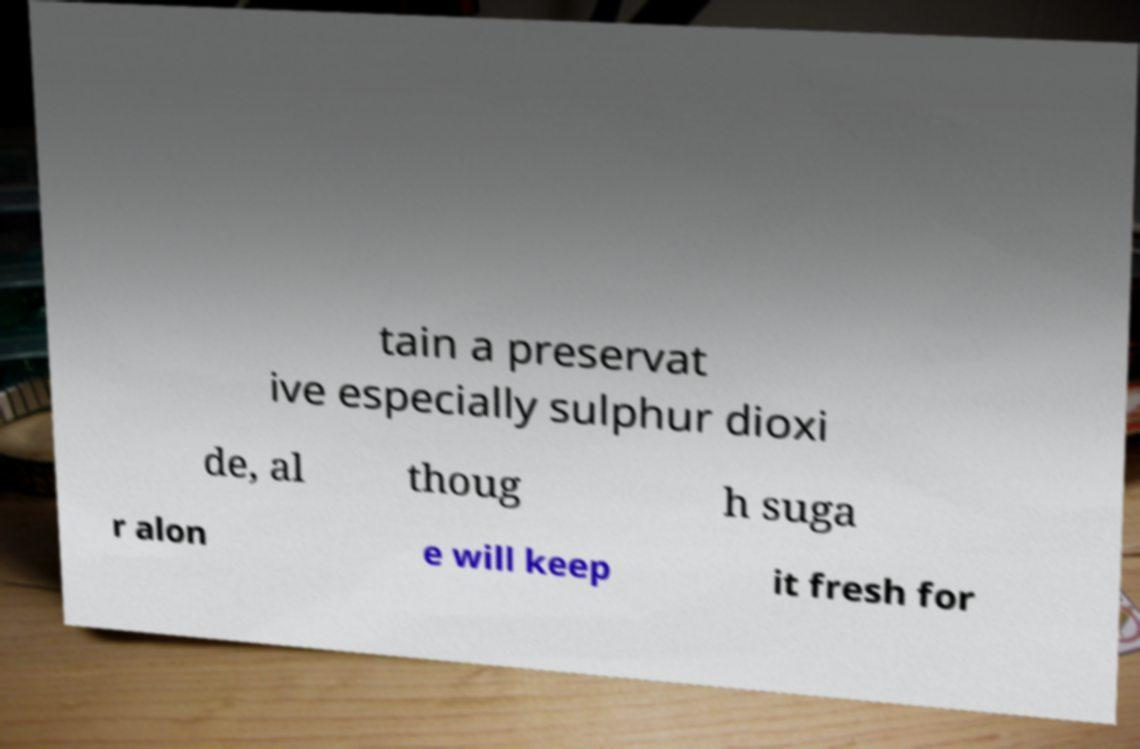For documentation purposes, I need the text within this image transcribed. Could you provide that? tain a preservat ive especially sulphur dioxi de, al thoug h suga r alon e will keep it fresh for 